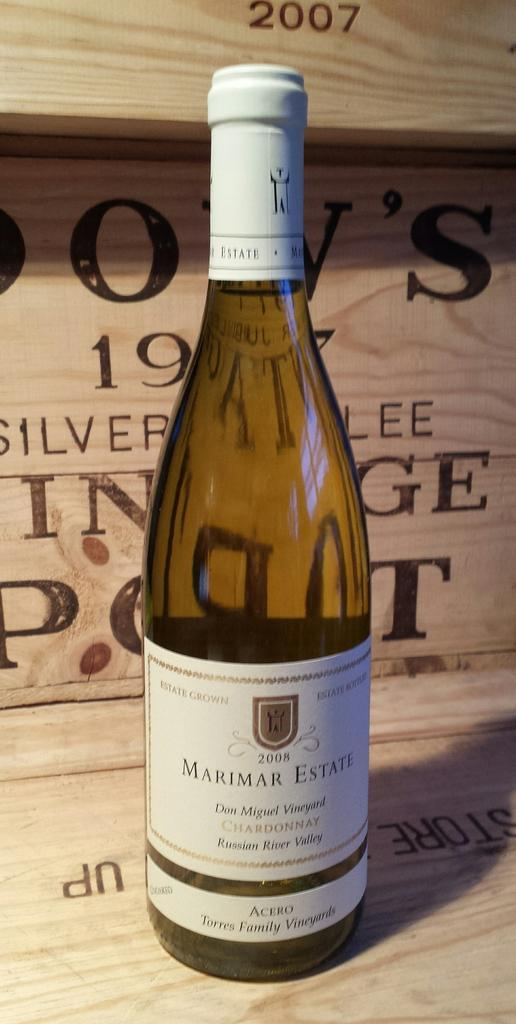<image>
Provide a brief description of the given image. A wine bottle is from the Don Miguel vineyard, per the label. 